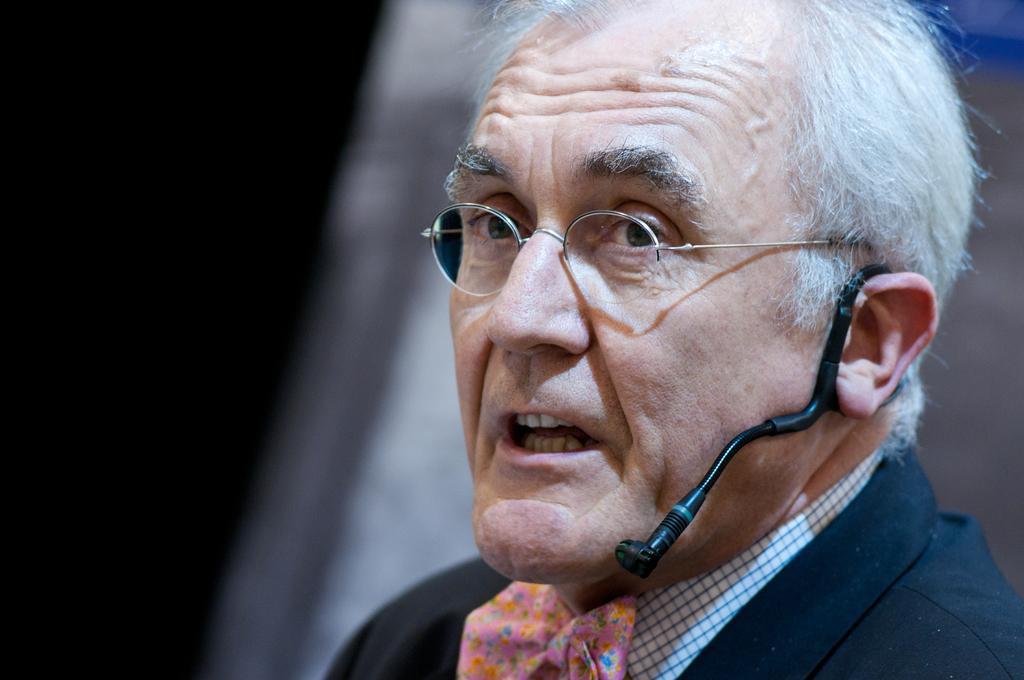Please provide a concise description of this image. In this image we can see a person wearing microphone and spectacles. 